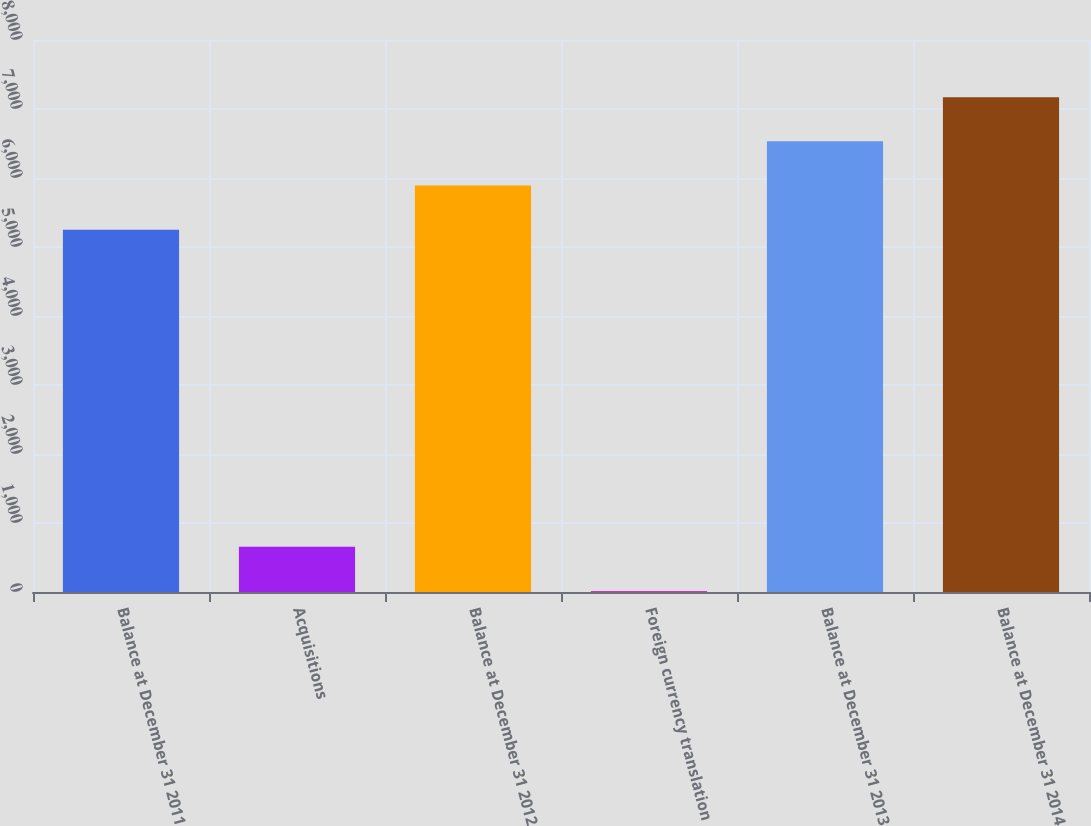Convert chart. <chart><loc_0><loc_0><loc_500><loc_500><bar_chart><fcel>Balance at December 31 2011<fcel>Acquisitions<fcel>Balance at December 31 2012<fcel>Foreign currency translation<fcel>Balance at December 31 2013<fcel>Balance at December 31 2014<nl><fcel>5251<fcel>654.2<fcel>5891.2<fcel>14<fcel>6531.4<fcel>7171.6<nl></chart> 